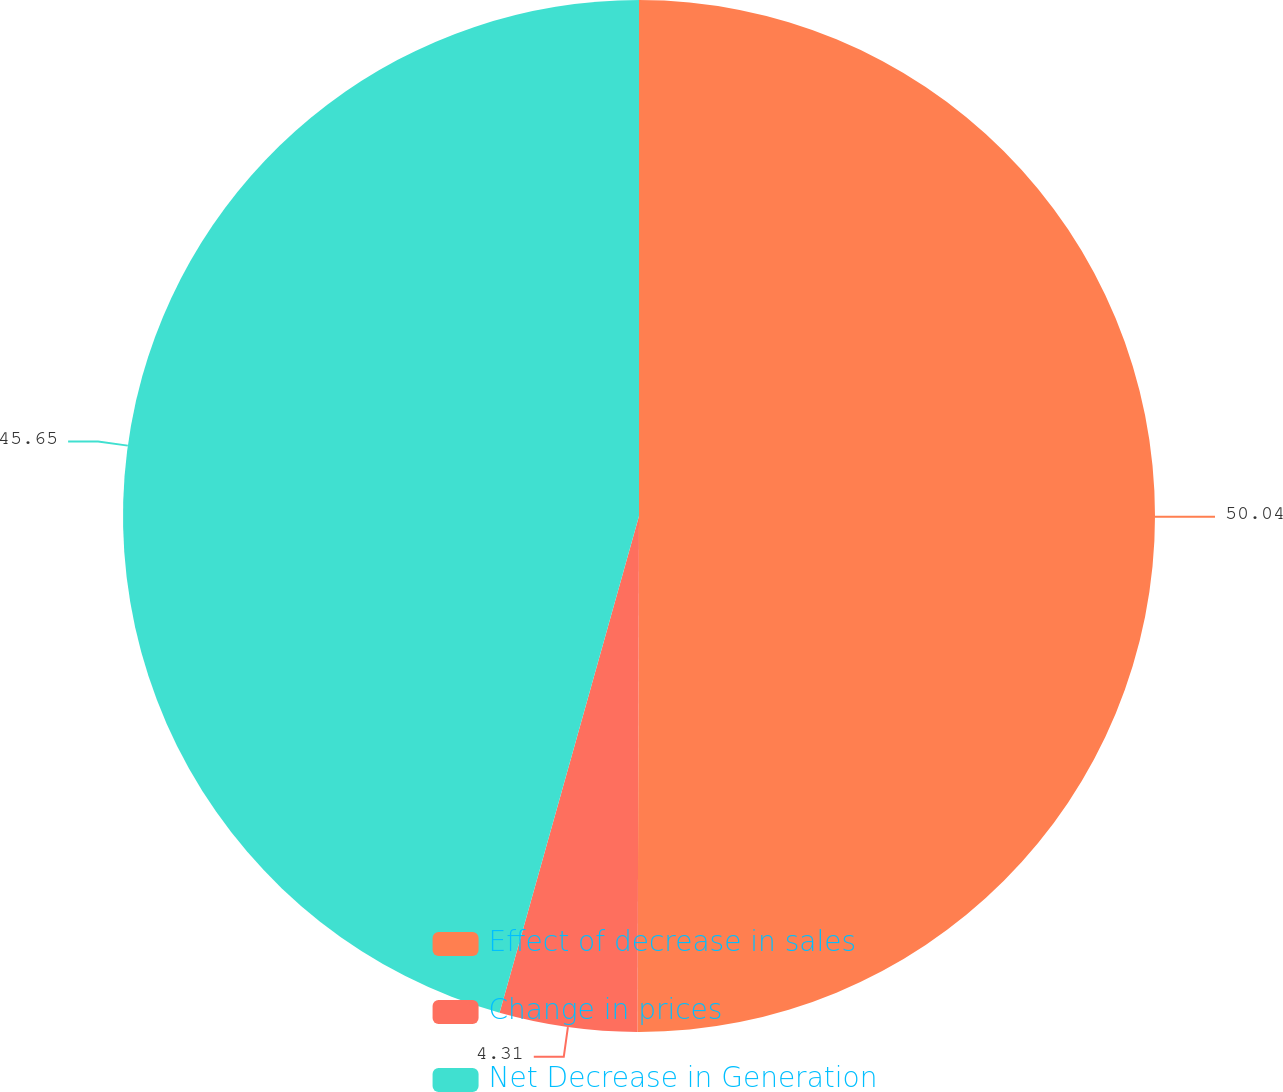Convert chart to OTSL. <chart><loc_0><loc_0><loc_500><loc_500><pie_chart><fcel>Effect of decrease in sales<fcel>Change in prices<fcel>Net Decrease in Generation<nl><fcel>50.05%<fcel>4.31%<fcel>45.65%<nl></chart> 